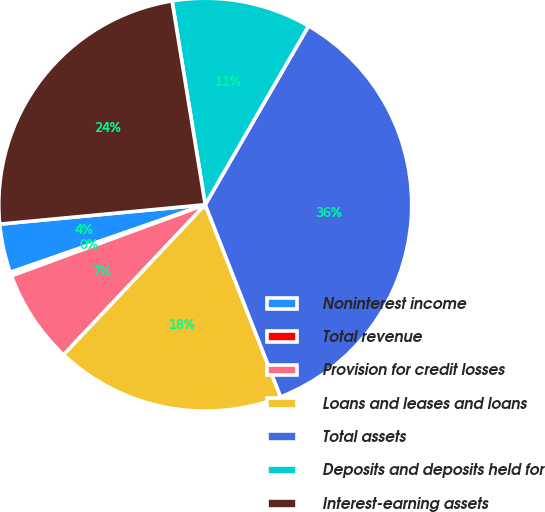Convert chart. <chart><loc_0><loc_0><loc_500><loc_500><pie_chart><fcel>Noninterest income<fcel>Total revenue<fcel>Provision for credit losses<fcel>Loans and leases and loans<fcel>Total assets<fcel>Deposits and deposits held for<fcel>Interest-earning assets<nl><fcel>3.82%<fcel>0.28%<fcel>7.36%<fcel>17.99%<fcel>35.71%<fcel>10.91%<fcel>23.93%<nl></chart> 